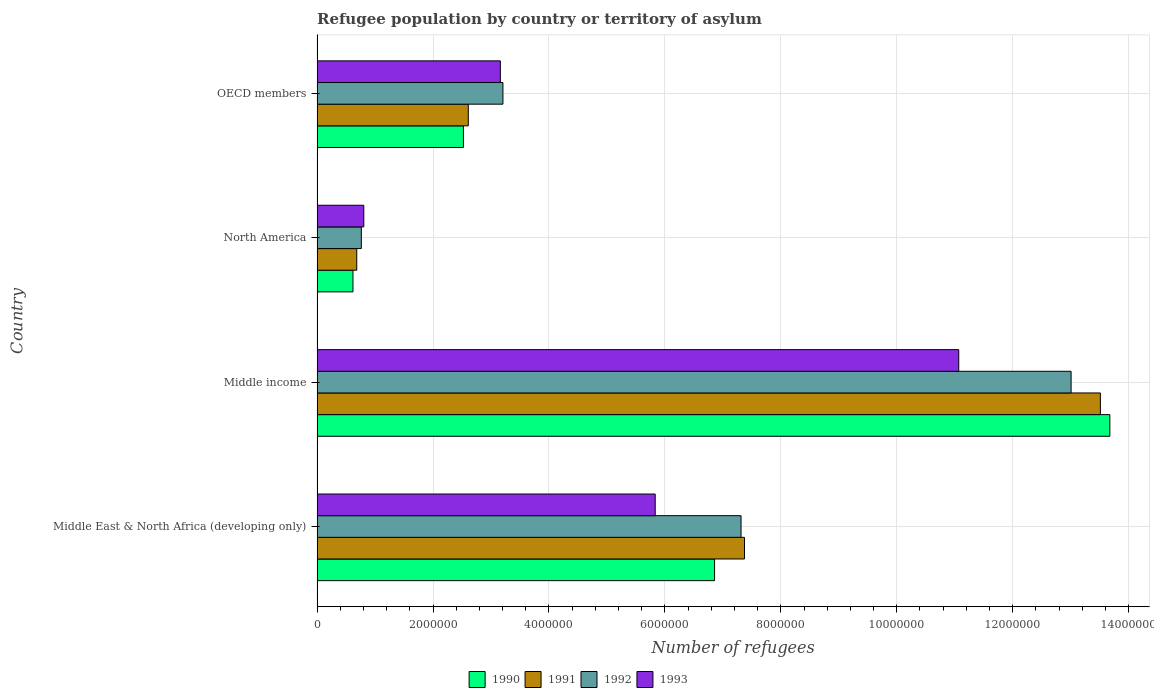Are the number of bars on each tick of the Y-axis equal?
Your answer should be compact. Yes. How many bars are there on the 1st tick from the top?
Keep it short and to the point. 4. How many bars are there on the 3rd tick from the bottom?
Offer a terse response. 4. In how many cases, is the number of bars for a given country not equal to the number of legend labels?
Your response must be concise. 0. What is the number of refugees in 1990 in OECD members?
Your answer should be compact. 2.52e+06. Across all countries, what is the maximum number of refugees in 1992?
Provide a succinct answer. 1.30e+07. Across all countries, what is the minimum number of refugees in 1992?
Offer a terse response. 7.64e+05. In which country was the number of refugees in 1991 minimum?
Keep it short and to the point. North America. What is the total number of refugees in 1990 in the graph?
Provide a short and direct response. 2.37e+07. What is the difference between the number of refugees in 1993 in North America and that in OECD members?
Keep it short and to the point. -2.36e+06. What is the difference between the number of refugees in 1990 in Middle income and the number of refugees in 1992 in North America?
Your answer should be compact. 1.29e+07. What is the average number of refugees in 1993 per country?
Offer a very short reply. 5.22e+06. What is the difference between the number of refugees in 1992 and number of refugees in 1993 in OECD members?
Offer a very short reply. 4.45e+04. What is the ratio of the number of refugees in 1991 in Middle income to that in OECD members?
Keep it short and to the point. 5.18. Is the number of refugees in 1990 in Middle income less than that in North America?
Provide a short and direct response. No. Is the difference between the number of refugees in 1992 in Middle East & North Africa (developing only) and Middle income greater than the difference between the number of refugees in 1993 in Middle East & North Africa (developing only) and Middle income?
Provide a short and direct response. No. What is the difference between the highest and the second highest number of refugees in 1991?
Your answer should be compact. 6.14e+06. What is the difference between the highest and the lowest number of refugees in 1993?
Provide a short and direct response. 1.03e+07. What does the 2nd bar from the top in Middle East & North Africa (developing only) represents?
Offer a very short reply. 1992. How many bars are there?
Offer a terse response. 16. Does the graph contain any zero values?
Offer a very short reply. No. Does the graph contain grids?
Your answer should be compact. Yes. How many legend labels are there?
Your response must be concise. 4. How are the legend labels stacked?
Keep it short and to the point. Horizontal. What is the title of the graph?
Provide a short and direct response. Refugee population by country or territory of asylum. Does "2013" appear as one of the legend labels in the graph?
Your response must be concise. No. What is the label or title of the X-axis?
Provide a short and direct response. Number of refugees. What is the Number of refugees in 1990 in Middle East & North Africa (developing only)?
Offer a very short reply. 6.86e+06. What is the Number of refugees in 1991 in Middle East & North Africa (developing only)?
Provide a short and direct response. 7.37e+06. What is the Number of refugees in 1992 in Middle East & North Africa (developing only)?
Your answer should be very brief. 7.31e+06. What is the Number of refugees of 1993 in Middle East & North Africa (developing only)?
Offer a very short reply. 5.83e+06. What is the Number of refugees in 1990 in Middle income?
Provide a succinct answer. 1.37e+07. What is the Number of refugees of 1991 in Middle income?
Ensure brevity in your answer.  1.35e+07. What is the Number of refugees of 1992 in Middle income?
Your answer should be very brief. 1.30e+07. What is the Number of refugees of 1993 in Middle income?
Your response must be concise. 1.11e+07. What is the Number of refugees of 1990 in North America?
Your answer should be compact. 6.20e+05. What is the Number of refugees in 1991 in North America?
Your answer should be very brief. 6.85e+05. What is the Number of refugees in 1992 in North America?
Offer a very short reply. 7.64e+05. What is the Number of refugees of 1993 in North America?
Make the answer very short. 8.06e+05. What is the Number of refugees of 1990 in OECD members?
Your answer should be compact. 2.52e+06. What is the Number of refugees of 1991 in OECD members?
Make the answer very short. 2.61e+06. What is the Number of refugees in 1992 in OECD members?
Offer a very short reply. 3.21e+06. What is the Number of refugees of 1993 in OECD members?
Keep it short and to the point. 3.16e+06. Across all countries, what is the maximum Number of refugees of 1990?
Offer a very short reply. 1.37e+07. Across all countries, what is the maximum Number of refugees of 1991?
Provide a succinct answer. 1.35e+07. Across all countries, what is the maximum Number of refugees of 1992?
Offer a very short reply. 1.30e+07. Across all countries, what is the maximum Number of refugees of 1993?
Offer a terse response. 1.11e+07. Across all countries, what is the minimum Number of refugees in 1990?
Offer a terse response. 6.20e+05. Across all countries, what is the minimum Number of refugees in 1991?
Ensure brevity in your answer.  6.85e+05. Across all countries, what is the minimum Number of refugees of 1992?
Provide a short and direct response. 7.64e+05. Across all countries, what is the minimum Number of refugees of 1993?
Provide a succinct answer. 8.06e+05. What is the total Number of refugees of 1990 in the graph?
Your answer should be compact. 2.37e+07. What is the total Number of refugees in 1991 in the graph?
Your answer should be compact. 2.42e+07. What is the total Number of refugees in 1992 in the graph?
Your answer should be very brief. 2.43e+07. What is the total Number of refugees of 1993 in the graph?
Provide a succinct answer. 2.09e+07. What is the difference between the Number of refugees in 1990 in Middle East & North Africa (developing only) and that in Middle income?
Your response must be concise. -6.82e+06. What is the difference between the Number of refugees of 1991 in Middle East & North Africa (developing only) and that in Middle income?
Ensure brevity in your answer.  -6.14e+06. What is the difference between the Number of refugees of 1992 in Middle East & North Africa (developing only) and that in Middle income?
Your answer should be compact. -5.69e+06. What is the difference between the Number of refugees in 1993 in Middle East & North Africa (developing only) and that in Middle income?
Your answer should be compact. -5.24e+06. What is the difference between the Number of refugees in 1990 in Middle East & North Africa (developing only) and that in North America?
Make the answer very short. 6.24e+06. What is the difference between the Number of refugees of 1991 in Middle East & North Africa (developing only) and that in North America?
Give a very brief answer. 6.69e+06. What is the difference between the Number of refugees in 1992 in Middle East & North Africa (developing only) and that in North America?
Keep it short and to the point. 6.55e+06. What is the difference between the Number of refugees of 1993 in Middle East & North Africa (developing only) and that in North America?
Give a very brief answer. 5.03e+06. What is the difference between the Number of refugees of 1990 in Middle East & North Africa (developing only) and that in OECD members?
Your answer should be very brief. 4.33e+06. What is the difference between the Number of refugees in 1991 in Middle East & North Africa (developing only) and that in OECD members?
Offer a very short reply. 4.76e+06. What is the difference between the Number of refugees of 1992 in Middle East & North Africa (developing only) and that in OECD members?
Give a very brief answer. 4.11e+06. What is the difference between the Number of refugees of 1993 in Middle East & North Africa (developing only) and that in OECD members?
Keep it short and to the point. 2.67e+06. What is the difference between the Number of refugees of 1990 in Middle income and that in North America?
Make the answer very short. 1.31e+07. What is the difference between the Number of refugees in 1991 in Middle income and that in North America?
Your answer should be very brief. 1.28e+07. What is the difference between the Number of refugees of 1992 in Middle income and that in North America?
Make the answer very short. 1.22e+07. What is the difference between the Number of refugees of 1993 in Middle income and that in North America?
Keep it short and to the point. 1.03e+07. What is the difference between the Number of refugees in 1990 in Middle income and that in OECD members?
Your answer should be very brief. 1.12e+07. What is the difference between the Number of refugees of 1991 in Middle income and that in OECD members?
Provide a short and direct response. 1.09e+07. What is the difference between the Number of refugees in 1992 in Middle income and that in OECD members?
Your answer should be compact. 9.80e+06. What is the difference between the Number of refugees in 1993 in Middle income and that in OECD members?
Provide a short and direct response. 7.91e+06. What is the difference between the Number of refugees in 1990 in North America and that in OECD members?
Offer a terse response. -1.91e+06. What is the difference between the Number of refugees in 1991 in North America and that in OECD members?
Provide a short and direct response. -1.92e+06. What is the difference between the Number of refugees in 1992 in North America and that in OECD members?
Your response must be concise. -2.44e+06. What is the difference between the Number of refugees in 1993 in North America and that in OECD members?
Your answer should be very brief. -2.36e+06. What is the difference between the Number of refugees in 1990 in Middle East & North Africa (developing only) and the Number of refugees in 1991 in Middle income?
Ensure brevity in your answer.  -6.66e+06. What is the difference between the Number of refugees of 1990 in Middle East & North Africa (developing only) and the Number of refugees of 1992 in Middle income?
Offer a very short reply. -6.15e+06. What is the difference between the Number of refugees of 1990 in Middle East & North Africa (developing only) and the Number of refugees of 1993 in Middle income?
Offer a terse response. -4.21e+06. What is the difference between the Number of refugees of 1991 in Middle East & North Africa (developing only) and the Number of refugees of 1992 in Middle income?
Provide a succinct answer. -5.63e+06. What is the difference between the Number of refugees of 1991 in Middle East & North Africa (developing only) and the Number of refugees of 1993 in Middle income?
Provide a succinct answer. -3.70e+06. What is the difference between the Number of refugees of 1992 in Middle East & North Africa (developing only) and the Number of refugees of 1993 in Middle income?
Your answer should be compact. -3.76e+06. What is the difference between the Number of refugees in 1990 in Middle East & North Africa (developing only) and the Number of refugees in 1991 in North America?
Your response must be concise. 6.17e+06. What is the difference between the Number of refugees of 1990 in Middle East & North Africa (developing only) and the Number of refugees of 1992 in North America?
Keep it short and to the point. 6.09e+06. What is the difference between the Number of refugees in 1990 in Middle East & North Africa (developing only) and the Number of refugees in 1993 in North America?
Keep it short and to the point. 6.05e+06. What is the difference between the Number of refugees in 1991 in Middle East & North Africa (developing only) and the Number of refugees in 1992 in North America?
Your response must be concise. 6.61e+06. What is the difference between the Number of refugees in 1991 in Middle East & North Africa (developing only) and the Number of refugees in 1993 in North America?
Give a very brief answer. 6.57e+06. What is the difference between the Number of refugees of 1992 in Middle East & North Africa (developing only) and the Number of refugees of 1993 in North America?
Give a very brief answer. 6.51e+06. What is the difference between the Number of refugees of 1990 in Middle East & North Africa (developing only) and the Number of refugees of 1991 in OECD members?
Your answer should be very brief. 4.25e+06. What is the difference between the Number of refugees in 1990 in Middle East & North Africa (developing only) and the Number of refugees in 1992 in OECD members?
Ensure brevity in your answer.  3.65e+06. What is the difference between the Number of refugees in 1990 in Middle East & North Africa (developing only) and the Number of refugees in 1993 in OECD members?
Give a very brief answer. 3.70e+06. What is the difference between the Number of refugees of 1991 in Middle East & North Africa (developing only) and the Number of refugees of 1992 in OECD members?
Your answer should be compact. 4.17e+06. What is the difference between the Number of refugees of 1991 in Middle East & North Africa (developing only) and the Number of refugees of 1993 in OECD members?
Offer a very short reply. 4.21e+06. What is the difference between the Number of refugees in 1992 in Middle East & North Africa (developing only) and the Number of refugees in 1993 in OECD members?
Give a very brief answer. 4.15e+06. What is the difference between the Number of refugees in 1990 in Middle income and the Number of refugees in 1991 in North America?
Keep it short and to the point. 1.30e+07. What is the difference between the Number of refugees of 1990 in Middle income and the Number of refugees of 1992 in North America?
Offer a very short reply. 1.29e+07. What is the difference between the Number of refugees of 1990 in Middle income and the Number of refugees of 1993 in North America?
Your answer should be compact. 1.29e+07. What is the difference between the Number of refugees in 1991 in Middle income and the Number of refugees in 1992 in North America?
Offer a terse response. 1.27e+07. What is the difference between the Number of refugees of 1991 in Middle income and the Number of refugees of 1993 in North America?
Make the answer very short. 1.27e+07. What is the difference between the Number of refugees of 1992 in Middle income and the Number of refugees of 1993 in North America?
Your answer should be very brief. 1.22e+07. What is the difference between the Number of refugees in 1990 in Middle income and the Number of refugees in 1991 in OECD members?
Offer a terse response. 1.11e+07. What is the difference between the Number of refugees of 1990 in Middle income and the Number of refugees of 1992 in OECD members?
Provide a short and direct response. 1.05e+07. What is the difference between the Number of refugees of 1990 in Middle income and the Number of refugees of 1993 in OECD members?
Provide a short and direct response. 1.05e+07. What is the difference between the Number of refugees of 1991 in Middle income and the Number of refugees of 1992 in OECD members?
Give a very brief answer. 1.03e+07. What is the difference between the Number of refugees of 1991 in Middle income and the Number of refugees of 1993 in OECD members?
Your answer should be very brief. 1.04e+07. What is the difference between the Number of refugees in 1992 in Middle income and the Number of refugees in 1993 in OECD members?
Provide a succinct answer. 9.85e+06. What is the difference between the Number of refugees in 1990 in North America and the Number of refugees in 1991 in OECD members?
Provide a short and direct response. -1.99e+06. What is the difference between the Number of refugees of 1990 in North America and the Number of refugees of 1992 in OECD members?
Make the answer very short. -2.59e+06. What is the difference between the Number of refugees in 1990 in North America and the Number of refugees in 1993 in OECD members?
Offer a terse response. -2.54e+06. What is the difference between the Number of refugees of 1991 in North America and the Number of refugees of 1992 in OECD members?
Provide a succinct answer. -2.52e+06. What is the difference between the Number of refugees in 1991 in North America and the Number of refugees in 1993 in OECD members?
Provide a succinct answer. -2.48e+06. What is the difference between the Number of refugees in 1992 in North America and the Number of refugees in 1993 in OECD members?
Provide a short and direct response. -2.40e+06. What is the average Number of refugees in 1990 per country?
Provide a short and direct response. 5.92e+06. What is the average Number of refugees of 1991 per country?
Offer a very short reply. 6.04e+06. What is the average Number of refugees of 1992 per country?
Provide a succinct answer. 6.07e+06. What is the average Number of refugees in 1993 per country?
Your answer should be compact. 5.22e+06. What is the difference between the Number of refugees of 1990 and Number of refugees of 1991 in Middle East & North Africa (developing only)?
Your response must be concise. -5.16e+05. What is the difference between the Number of refugees of 1990 and Number of refugees of 1992 in Middle East & North Africa (developing only)?
Provide a succinct answer. -4.57e+05. What is the difference between the Number of refugees of 1990 and Number of refugees of 1993 in Middle East & North Africa (developing only)?
Offer a terse response. 1.02e+06. What is the difference between the Number of refugees of 1991 and Number of refugees of 1992 in Middle East & North Africa (developing only)?
Ensure brevity in your answer.  5.95e+04. What is the difference between the Number of refugees of 1991 and Number of refugees of 1993 in Middle East & North Africa (developing only)?
Make the answer very short. 1.54e+06. What is the difference between the Number of refugees of 1992 and Number of refugees of 1993 in Middle East & North Africa (developing only)?
Provide a short and direct response. 1.48e+06. What is the difference between the Number of refugees of 1990 and Number of refugees of 1991 in Middle income?
Keep it short and to the point. 1.63e+05. What is the difference between the Number of refugees of 1990 and Number of refugees of 1992 in Middle income?
Your response must be concise. 6.69e+05. What is the difference between the Number of refugees in 1990 and Number of refugees in 1993 in Middle income?
Make the answer very short. 2.61e+06. What is the difference between the Number of refugees in 1991 and Number of refugees in 1992 in Middle income?
Keep it short and to the point. 5.05e+05. What is the difference between the Number of refugees of 1991 and Number of refugees of 1993 in Middle income?
Offer a very short reply. 2.44e+06. What is the difference between the Number of refugees in 1992 and Number of refugees in 1993 in Middle income?
Provide a short and direct response. 1.94e+06. What is the difference between the Number of refugees in 1990 and Number of refugees in 1991 in North America?
Offer a very short reply. -6.52e+04. What is the difference between the Number of refugees of 1990 and Number of refugees of 1992 in North America?
Make the answer very short. -1.44e+05. What is the difference between the Number of refugees in 1990 and Number of refugees in 1993 in North America?
Provide a short and direct response. -1.87e+05. What is the difference between the Number of refugees of 1991 and Number of refugees of 1992 in North America?
Keep it short and to the point. -7.89e+04. What is the difference between the Number of refugees of 1991 and Number of refugees of 1993 in North America?
Your answer should be compact. -1.22e+05. What is the difference between the Number of refugees of 1992 and Number of refugees of 1993 in North America?
Provide a short and direct response. -4.26e+04. What is the difference between the Number of refugees of 1990 and Number of refugees of 1991 in OECD members?
Give a very brief answer. -8.42e+04. What is the difference between the Number of refugees in 1990 and Number of refugees in 1992 in OECD members?
Provide a short and direct response. -6.82e+05. What is the difference between the Number of refugees of 1990 and Number of refugees of 1993 in OECD members?
Ensure brevity in your answer.  -6.37e+05. What is the difference between the Number of refugees of 1991 and Number of refugees of 1992 in OECD members?
Provide a succinct answer. -5.98e+05. What is the difference between the Number of refugees in 1991 and Number of refugees in 1993 in OECD members?
Your answer should be very brief. -5.53e+05. What is the difference between the Number of refugees of 1992 and Number of refugees of 1993 in OECD members?
Your answer should be very brief. 4.45e+04. What is the ratio of the Number of refugees in 1990 in Middle East & North Africa (developing only) to that in Middle income?
Offer a terse response. 0.5. What is the ratio of the Number of refugees of 1991 in Middle East & North Africa (developing only) to that in Middle income?
Offer a terse response. 0.55. What is the ratio of the Number of refugees in 1992 in Middle East & North Africa (developing only) to that in Middle income?
Give a very brief answer. 0.56. What is the ratio of the Number of refugees in 1993 in Middle East & North Africa (developing only) to that in Middle income?
Provide a short and direct response. 0.53. What is the ratio of the Number of refugees of 1990 in Middle East & North Africa (developing only) to that in North America?
Your response must be concise. 11.07. What is the ratio of the Number of refugees in 1991 in Middle East & North Africa (developing only) to that in North America?
Provide a succinct answer. 10.77. What is the ratio of the Number of refugees of 1992 in Middle East & North Africa (developing only) to that in North America?
Your answer should be compact. 9.58. What is the ratio of the Number of refugees in 1993 in Middle East & North Africa (developing only) to that in North America?
Ensure brevity in your answer.  7.23. What is the ratio of the Number of refugees of 1990 in Middle East & North Africa (developing only) to that in OECD members?
Offer a terse response. 2.72. What is the ratio of the Number of refugees of 1991 in Middle East & North Africa (developing only) to that in OECD members?
Ensure brevity in your answer.  2.83. What is the ratio of the Number of refugees in 1992 in Middle East & North Africa (developing only) to that in OECD members?
Your answer should be very brief. 2.28. What is the ratio of the Number of refugees of 1993 in Middle East & North Africa (developing only) to that in OECD members?
Your answer should be very brief. 1.84. What is the ratio of the Number of refugees of 1990 in Middle income to that in North America?
Ensure brevity in your answer.  22.07. What is the ratio of the Number of refugees of 1991 in Middle income to that in North America?
Your answer should be very brief. 19.73. What is the ratio of the Number of refugees in 1992 in Middle income to that in North America?
Your answer should be very brief. 17.03. What is the ratio of the Number of refugees of 1993 in Middle income to that in North America?
Offer a very short reply. 13.73. What is the ratio of the Number of refugees in 1990 in Middle income to that in OECD members?
Provide a short and direct response. 5.42. What is the ratio of the Number of refugees in 1991 in Middle income to that in OECD members?
Offer a terse response. 5.18. What is the ratio of the Number of refugees of 1992 in Middle income to that in OECD members?
Ensure brevity in your answer.  4.06. What is the ratio of the Number of refugees of 1993 in Middle income to that in OECD members?
Provide a short and direct response. 3.5. What is the ratio of the Number of refugees in 1990 in North America to that in OECD members?
Offer a terse response. 0.25. What is the ratio of the Number of refugees in 1991 in North America to that in OECD members?
Keep it short and to the point. 0.26. What is the ratio of the Number of refugees in 1992 in North America to that in OECD members?
Ensure brevity in your answer.  0.24. What is the ratio of the Number of refugees of 1993 in North America to that in OECD members?
Provide a succinct answer. 0.26. What is the difference between the highest and the second highest Number of refugees of 1990?
Make the answer very short. 6.82e+06. What is the difference between the highest and the second highest Number of refugees of 1991?
Keep it short and to the point. 6.14e+06. What is the difference between the highest and the second highest Number of refugees in 1992?
Ensure brevity in your answer.  5.69e+06. What is the difference between the highest and the second highest Number of refugees of 1993?
Offer a very short reply. 5.24e+06. What is the difference between the highest and the lowest Number of refugees of 1990?
Your answer should be compact. 1.31e+07. What is the difference between the highest and the lowest Number of refugees in 1991?
Your answer should be compact. 1.28e+07. What is the difference between the highest and the lowest Number of refugees in 1992?
Your answer should be compact. 1.22e+07. What is the difference between the highest and the lowest Number of refugees of 1993?
Give a very brief answer. 1.03e+07. 